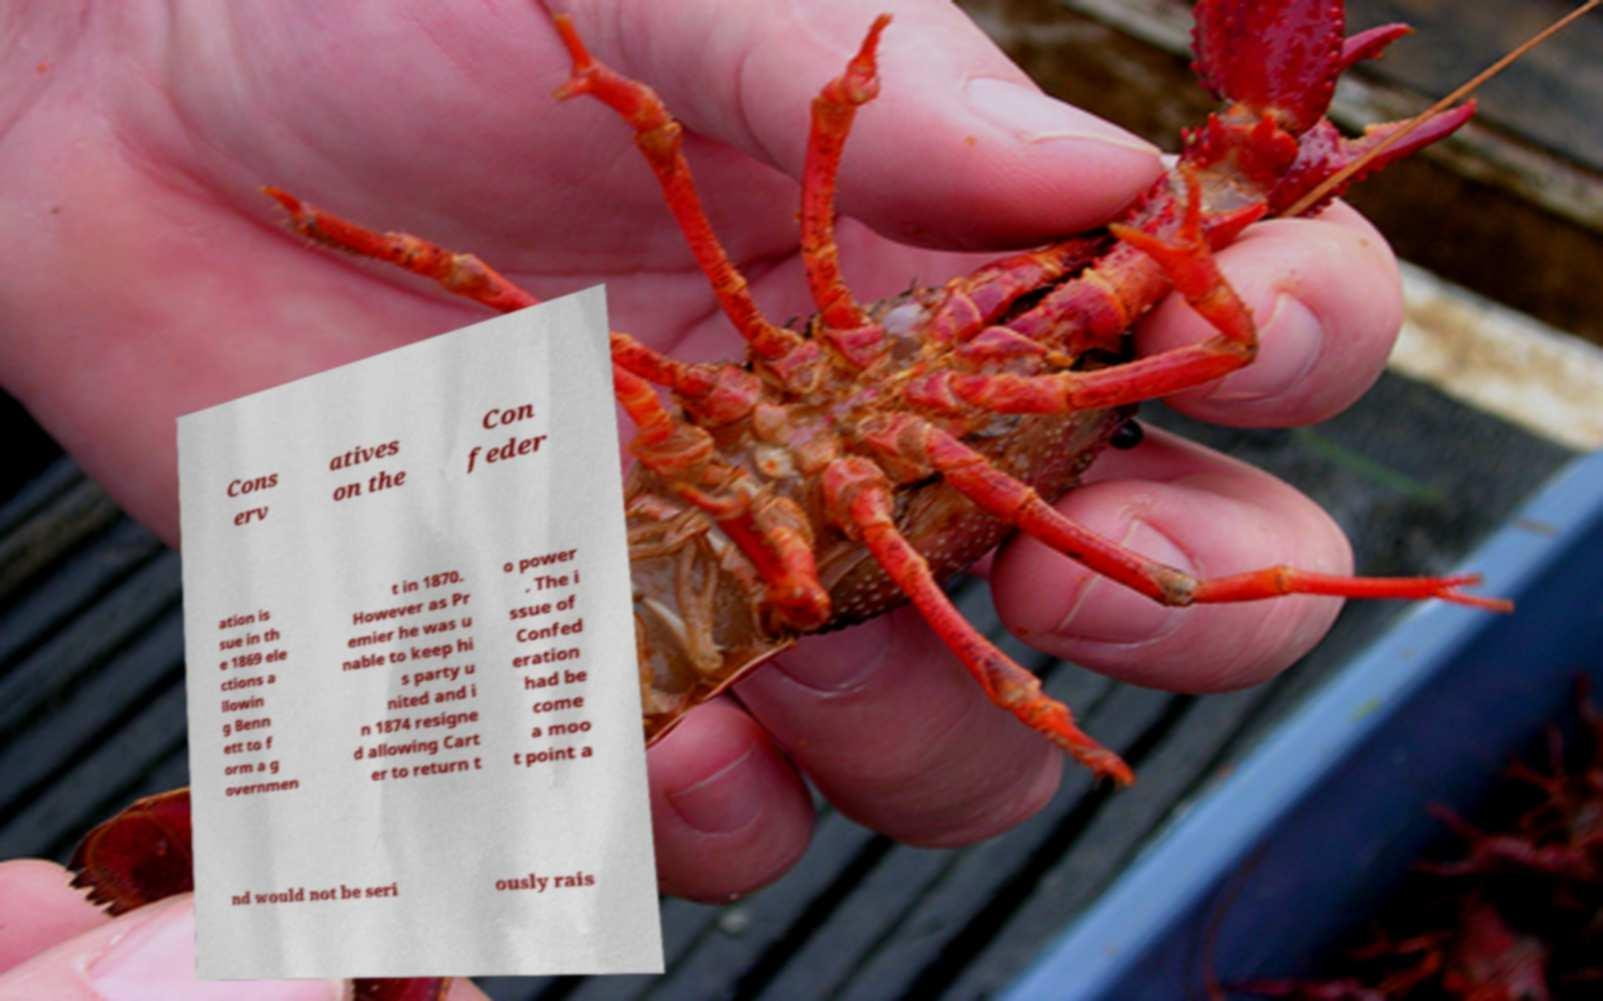Please identify and transcribe the text found in this image. Cons erv atives on the Con feder ation is sue in th e 1869 ele ctions a llowin g Benn ett to f orm a g overnmen t in 1870. However as Pr emier he was u nable to keep hi s party u nited and i n 1874 resigne d allowing Cart er to return t o power . The i ssue of Confed eration had be come a moo t point a nd would not be seri ously rais 